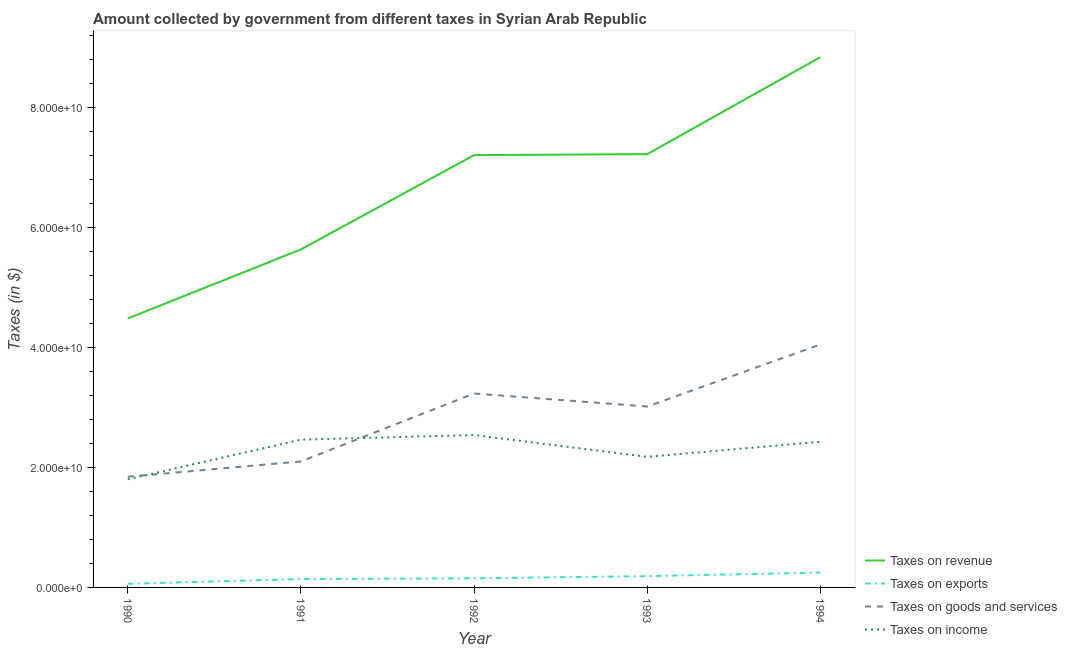How many different coloured lines are there?
Keep it short and to the point. 4. What is the amount collected as tax on revenue in 1994?
Your answer should be compact. 8.84e+1. Across all years, what is the maximum amount collected as tax on goods?
Your answer should be compact. 4.05e+1. Across all years, what is the minimum amount collected as tax on exports?
Your response must be concise. 6.04e+08. In which year was the amount collected as tax on revenue minimum?
Keep it short and to the point. 1990. What is the total amount collected as tax on income in the graph?
Ensure brevity in your answer.  1.14e+11. What is the difference between the amount collected as tax on income in 1990 and that in 1992?
Your answer should be compact. -7.38e+09. What is the difference between the amount collected as tax on goods in 1993 and the amount collected as tax on income in 1992?
Provide a short and direct response. 4.76e+09. What is the average amount collected as tax on goods per year?
Offer a terse response. 2.85e+1. In the year 1990, what is the difference between the amount collected as tax on revenue and amount collected as tax on exports?
Ensure brevity in your answer.  4.42e+1. In how many years, is the amount collected as tax on goods greater than 76000000000 $?
Keep it short and to the point. 0. What is the ratio of the amount collected as tax on exports in 1991 to that in 1994?
Offer a terse response. 0.56. Is the difference between the amount collected as tax on revenue in 1991 and 1992 greater than the difference between the amount collected as tax on exports in 1991 and 1992?
Provide a succinct answer. No. What is the difference between the highest and the second highest amount collected as tax on goods?
Provide a short and direct response. 8.17e+09. What is the difference between the highest and the lowest amount collected as tax on goods?
Your answer should be compact. 2.21e+1. Is the sum of the amount collected as tax on exports in 1992 and 1993 greater than the maximum amount collected as tax on revenue across all years?
Provide a succinct answer. No. Is it the case that in every year, the sum of the amount collected as tax on revenue and amount collected as tax on exports is greater than the amount collected as tax on goods?
Provide a succinct answer. Yes. Does the amount collected as tax on goods monotonically increase over the years?
Your answer should be very brief. No. Is the amount collected as tax on goods strictly greater than the amount collected as tax on exports over the years?
Offer a terse response. Yes. Is the amount collected as tax on goods strictly less than the amount collected as tax on income over the years?
Provide a short and direct response. No. How many lines are there?
Provide a short and direct response. 4. How many years are there in the graph?
Ensure brevity in your answer.  5. Does the graph contain any zero values?
Make the answer very short. No. Where does the legend appear in the graph?
Your response must be concise. Bottom right. What is the title of the graph?
Make the answer very short. Amount collected by government from different taxes in Syrian Arab Republic. Does "WHO" appear as one of the legend labels in the graph?
Keep it short and to the point. No. What is the label or title of the X-axis?
Your answer should be compact. Year. What is the label or title of the Y-axis?
Keep it short and to the point. Taxes (in $). What is the Taxes (in $) of Taxes on revenue in 1990?
Offer a terse response. 4.48e+1. What is the Taxes (in $) in Taxes on exports in 1990?
Your answer should be very brief. 6.04e+08. What is the Taxes (in $) in Taxes on goods and services in 1990?
Your answer should be compact. 1.85e+1. What is the Taxes (in $) in Taxes on income in 1990?
Make the answer very short. 1.80e+1. What is the Taxes (in $) in Taxes on revenue in 1991?
Offer a terse response. 5.64e+1. What is the Taxes (in $) in Taxes on exports in 1991?
Ensure brevity in your answer.  1.39e+09. What is the Taxes (in $) of Taxes on goods and services in 1991?
Make the answer very short. 2.10e+1. What is the Taxes (in $) of Taxes on income in 1991?
Give a very brief answer. 2.46e+1. What is the Taxes (in $) in Taxes on revenue in 1992?
Your answer should be very brief. 7.21e+1. What is the Taxes (in $) in Taxes on exports in 1992?
Provide a succinct answer. 1.52e+09. What is the Taxes (in $) in Taxes on goods and services in 1992?
Your response must be concise. 3.23e+1. What is the Taxes (in $) of Taxes on income in 1992?
Give a very brief answer. 2.54e+1. What is the Taxes (in $) of Taxes on revenue in 1993?
Give a very brief answer. 7.22e+1. What is the Taxes (in $) in Taxes on exports in 1993?
Offer a terse response. 1.88e+09. What is the Taxes (in $) of Taxes on goods and services in 1993?
Ensure brevity in your answer.  3.02e+1. What is the Taxes (in $) of Taxes on income in 1993?
Offer a very short reply. 2.18e+1. What is the Taxes (in $) in Taxes on revenue in 1994?
Your answer should be compact. 8.84e+1. What is the Taxes (in $) in Taxes on exports in 1994?
Provide a short and direct response. 2.48e+09. What is the Taxes (in $) in Taxes on goods and services in 1994?
Offer a terse response. 4.05e+1. What is the Taxes (in $) of Taxes on income in 1994?
Offer a terse response. 2.43e+1. Across all years, what is the maximum Taxes (in $) in Taxes on revenue?
Ensure brevity in your answer.  8.84e+1. Across all years, what is the maximum Taxes (in $) in Taxes on exports?
Provide a succinct answer. 2.48e+09. Across all years, what is the maximum Taxes (in $) of Taxes on goods and services?
Provide a short and direct response. 4.05e+1. Across all years, what is the maximum Taxes (in $) in Taxes on income?
Make the answer very short. 2.54e+1. Across all years, what is the minimum Taxes (in $) in Taxes on revenue?
Keep it short and to the point. 4.48e+1. Across all years, what is the minimum Taxes (in $) of Taxes on exports?
Ensure brevity in your answer.  6.04e+08. Across all years, what is the minimum Taxes (in $) in Taxes on goods and services?
Provide a short and direct response. 1.85e+1. Across all years, what is the minimum Taxes (in $) in Taxes on income?
Offer a terse response. 1.80e+1. What is the total Taxes (in $) in Taxes on revenue in the graph?
Offer a terse response. 3.34e+11. What is the total Taxes (in $) of Taxes on exports in the graph?
Your answer should be very brief. 7.88e+09. What is the total Taxes (in $) of Taxes on goods and services in the graph?
Your answer should be very brief. 1.42e+11. What is the total Taxes (in $) in Taxes on income in the graph?
Ensure brevity in your answer.  1.14e+11. What is the difference between the Taxes (in $) in Taxes on revenue in 1990 and that in 1991?
Offer a very short reply. -1.15e+1. What is the difference between the Taxes (in $) in Taxes on exports in 1990 and that in 1991?
Give a very brief answer. -7.88e+08. What is the difference between the Taxes (in $) in Taxes on goods and services in 1990 and that in 1991?
Your response must be concise. -2.56e+09. What is the difference between the Taxes (in $) of Taxes on income in 1990 and that in 1991?
Ensure brevity in your answer.  -6.61e+09. What is the difference between the Taxes (in $) in Taxes on revenue in 1990 and that in 1992?
Keep it short and to the point. -2.72e+1. What is the difference between the Taxes (in $) of Taxes on exports in 1990 and that in 1992?
Make the answer very short. -9.19e+08. What is the difference between the Taxes (in $) of Taxes on goods and services in 1990 and that in 1992?
Keep it short and to the point. -1.39e+1. What is the difference between the Taxes (in $) of Taxes on income in 1990 and that in 1992?
Make the answer very short. -7.38e+09. What is the difference between the Taxes (in $) in Taxes on revenue in 1990 and that in 1993?
Provide a succinct answer. -2.74e+1. What is the difference between the Taxes (in $) of Taxes on exports in 1990 and that in 1993?
Offer a very short reply. -1.28e+09. What is the difference between the Taxes (in $) of Taxes on goods and services in 1990 and that in 1993?
Your answer should be compact. -1.17e+1. What is the difference between the Taxes (in $) in Taxes on income in 1990 and that in 1993?
Offer a terse response. -3.75e+09. What is the difference between the Taxes (in $) of Taxes on revenue in 1990 and that in 1994?
Provide a short and direct response. -4.36e+1. What is the difference between the Taxes (in $) in Taxes on exports in 1990 and that in 1994?
Provide a short and direct response. -1.87e+09. What is the difference between the Taxes (in $) in Taxes on goods and services in 1990 and that in 1994?
Provide a succinct answer. -2.21e+1. What is the difference between the Taxes (in $) in Taxes on income in 1990 and that in 1994?
Provide a succinct answer. -6.26e+09. What is the difference between the Taxes (in $) in Taxes on revenue in 1991 and that in 1992?
Keep it short and to the point. -1.57e+1. What is the difference between the Taxes (in $) in Taxes on exports in 1991 and that in 1992?
Offer a terse response. -1.31e+08. What is the difference between the Taxes (in $) of Taxes on goods and services in 1991 and that in 1992?
Provide a short and direct response. -1.13e+1. What is the difference between the Taxes (in $) of Taxes on income in 1991 and that in 1992?
Your answer should be compact. -7.67e+08. What is the difference between the Taxes (in $) of Taxes on revenue in 1991 and that in 1993?
Your answer should be compact. -1.59e+1. What is the difference between the Taxes (in $) of Taxes on exports in 1991 and that in 1993?
Provide a succinct answer. -4.92e+08. What is the difference between the Taxes (in $) in Taxes on goods and services in 1991 and that in 1993?
Your answer should be very brief. -9.16e+09. What is the difference between the Taxes (in $) of Taxes on income in 1991 and that in 1993?
Give a very brief answer. 2.86e+09. What is the difference between the Taxes (in $) of Taxes on revenue in 1991 and that in 1994?
Keep it short and to the point. -3.21e+1. What is the difference between the Taxes (in $) of Taxes on exports in 1991 and that in 1994?
Provide a short and direct response. -1.08e+09. What is the difference between the Taxes (in $) in Taxes on goods and services in 1991 and that in 1994?
Provide a short and direct response. -1.95e+1. What is the difference between the Taxes (in $) of Taxes on income in 1991 and that in 1994?
Your answer should be very brief. 3.50e+08. What is the difference between the Taxes (in $) of Taxes on revenue in 1992 and that in 1993?
Your answer should be compact. -1.62e+08. What is the difference between the Taxes (in $) in Taxes on exports in 1992 and that in 1993?
Your answer should be compact. -3.61e+08. What is the difference between the Taxes (in $) of Taxes on goods and services in 1992 and that in 1993?
Your answer should be compact. 2.17e+09. What is the difference between the Taxes (in $) of Taxes on income in 1992 and that in 1993?
Your answer should be compact. 3.63e+09. What is the difference between the Taxes (in $) of Taxes on revenue in 1992 and that in 1994?
Your response must be concise. -1.63e+1. What is the difference between the Taxes (in $) of Taxes on exports in 1992 and that in 1994?
Keep it short and to the point. -9.54e+08. What is the difference between the Taxes (in $) in Taxes on goods and services in 1992 and that in 1994?
Offer a very short reply. -8.17e+09. What is the difference between the Taxes (in $) of Taxes on income in 1992 and that in 1994?
Keep it short and to the point. 1.12e+09. What is the difference between the Taxes (in $) in Taxes on revenue in 1993 and that in 1994?
Give a very brief answer. -1.62e+1. What is the difference between the Taxes (in $) of Taxes on exports in 1993 and that in 1994?
Your answer should be very brief. -5.93e+08. What is the difference between the Taxes (in $) in Taxes on goods and services in 1993 and that in 1994?
Keep it short and to the point. -1.03e+1. What is the difference between the Taxes (in $) of Taxes on income in 1993 and that in 1994?
Your answer should be compact. -2.52e+09. What is the difference between the Taxes (in $) of Taxes on revenue in 1990 and the Taxes (in $) of Taxes on exports in 1991?
Provide a short and direct response. 4.35e+1. What is the difference between the Taxes (in $) of Taxes on revenue in 1990 and the Taxes (in $) of Taxes on goods and services in 1991?
Your response must be concise. 2.38e+1. What is the difference between the Taxes (in $) in Taxes on revenue in 1990 and the Taxes (in $) in Taxes on income in 1991?
Your answer should be compact. 2.02e+1. What is the difference between the Taxes (in $) of Taxes on exports in 1990 and the Taxes (in $) of Taxes on goods and services in 1991?
Keep it short and to the point. -2.04e+1. What is the difference between the Taxes (in $) of Taxes on exports in 1990 and the Taxes (in $) of Taxes on income in 1991?
Provide a short and direct response. -2.40e+1. What is the difference between the Taxes (in $) of Taxes on goods and services in 1990 and the Taxes (in $) of Taxes on income in 1991?
Your response must be concise. -6.19e+09. What is the difference between the Taxes (in $) of Taxes on revenue in 1990 and the Taxes (in $) of Taxes on exports in 1992?
Give a very brief answer. 4.33e+1. What is the difference between the Taxes (in $) in Taxes on revenue in 1990 and the Taxes (in $) in Taxes on goods and services in 1992?
Your answer should be compact. 1.25e+1. What is the difference between the Taxes (in $) in Taxes on revenue in 1990 and the Taxes (in $) in Taxes on income in 1992?
Keep it short and to the point. 1.94e+1. What is the difference between the Taxes (in $) in Taxes on exports in 1990 and the Taxes (in $) in Taxes on goods and services in 1992?
Your answer should be compact. -3.17e+1. What is the difference between the Taxes (in $) in Taxes on exports in 1990 and the Taxes (in $) in Taxes on income in 1992?
Keep it short and to the point. -2.48e+1. What is the difference between the Taxes (in $) in Taxes on goods and services in 1990 and the Taxes (in $) in Taxes on income in 1992?
Your answer should be very brief. -6.96e+09. What is the difference between the Taxes (in $) of Taxes on revenue in 1990 and the Taxes (in $) of Taxes on exports in 1993?
Keep it short and to the point. 4.30e+1. What is the difference between the Taxes (in $) of Taxes on revenue in 1990 and the Taxes (in $) of Taxes on goods and services in 1993?
Offer a terse response. 1.47e+1. What is the difference between the Taxes (in $) in Taxes on revenue in 1990 and the Taxes (in $) in Taxes on income in 1993?
Your answer should be very brief. 2.31e+1. What is the difference between the Taxes (in $) of Taxes on exports in 1990 and the Taxes (in $) of Taxes on goods and services in 1993?
Give a very brief answer. -2.96e+1. What is the difference between the Taxes (in $) of Taxes on exports in 1990 and the Taxes (in $) of Taxes on income in 1993?
Make the answer very short. -2.12e+1. What is the difference between the Taxes (in $) in Taxes on goods and services in 1990 and the Taxes (in $) in Taxes on income in 1993?
Provide a succinct answer. -3.32e+09. What is the difference between the Taxes (in $) in Taxes on revenue in 1990 and the Taxes (in $) in Taxes on exports in 1994?
Make the answer very short. 4.24e+1. What is the difference between the Taxes (in $) in Taxes on revenue in 1990 and the Taxes (in $) in Taxes on goods and services in 1994?
Offer a very short reply. 4.34e+09. What is the difference between the Taxes (in $) of Taxes on revenue in 1990 and the Taxes (in $) of Taxes on income in 1994?
Keep it short and to the point. 2.06e+1. What is the difference between the Taxes (in $) of Taxes on exports in 1990 and the Taxes (in $) of Taxes on goods and services in 1994?
Offer a terse response. -3.99e+1. What is the difference between the Taxes (in $) in Taxes on exports in 1990 and the Taxes (in $) in Taxes on income in 1994?
Ensure brevity in your answer.  -2.37e+1. What is the difference between the Taxes (in $) of Taxes on goods and services in 1990 and the Taxes (in $) of Taxes on income in 1994?
Offer a terse response. -5.84e+09. What is the difference between the Taxes (in $) of Taxes on revenue in 1991 and the Taxes (in $) of Taxes on exports in 1992?
Keep it short and to the point. 5.48e+1. What is the difference between the Taxes (in $) of Taxes on revenue in 1991 and the Taxes (in $) of Taxes on goods and services in 1992?
Your response must be concise. 2.40e+1. What is the difference between the Taxes (in $) of Taxes on revenue in 1991 and the Taxes (in $) of Taxes on income in 1992?
Your answer should be very brief. 3.10e+1. What is the difference between the Taxes (in $) in Taxes on exports in 1991 and the Taxes (in $) in Taxes on goods and services in 1992?
Provide a succinct answer. -3.09e+1. What is the difference between the Taxes (in $) in Taxes on exports in 1991 and the Taxes (in $) in Taxes on income in 1992?
Offer a terse response. -2.40e+1. What is the difference between the Taxes (in $) in Taxes on goods and services in 1991 and the Taxes (in $) in Taxes on income in 1992?
Your answer should be compact. -4.40e+09. What is the difference between the Taxes (in $) in Taxes on revenue in 1991 and the Taxes (in $) in Taxes on exports in 1993?
Your answer should be compact. 5.45e+1. What is the difference between the Taxes (in $) in Taxes on revenue in 1991 and the Taxes (in $) in Taxes on goods and services in 1993?
Give a very brief answer. 2.62e+1. What is the difference between the Taxes (in $) in Taxes on revenue in 1991 and the Taxes (in $) in Taxes on income in 1993?
Provide a succinct answer. 3.46e+1. What is the difference between the Taxes (in $) of Taxes on exports in 1991 and the Taxes (in $) of Taxes on goods and services in 1993?
Ensure brevity in your answer.  -2.88e+1. What is the difference between the Taxes (in $) of Taxes on exports in 1991 and the Taxes (in $) of Taxes on income in 1993?
Your answer should be very brief. -2.04e+1. What is the difference between the Taxes (in $) in Taxes on goods and services in 1991 and the Taxes (in $) in Taxes on income in 1993?
Provide a short and direct response. -7.69e+08. What is the difference between the Taxes (in $) in Taxes on revenue in 1991 and the Taxes (in $) in Taxes on exports in 1994?
Keep it short and to the point. 5.39e+1. What is the difference between the Taxes (in $) in Taxes on revenue in 1991 and the Taxes (in $) in Taxes on goods and services in 1994?
Your answer should be compact. 1.59e+1. What is the difference between the Taxes (in $) of Taxes on revenue in 1991 and the Taxes (in $) of Taxes on income in 1994?
Keep it short and to the point. 3.21e+1. What is the difference between the Taxes (in $) in Taxes on exports in 1991 and the Taxes (in $) in Taxes on goods and services in 1994?
Offer a very short reply. -3.91e+1. What is the difference between the Taxes (in $) of Taxes on exports in 1991 and the Taxes (in $) of Taxes on income in 1994?
Your answer should be very brief. -2.29e+1. What is the difference between the Taxes (in $) of Taxes on goods and services in 1991 and the Taxes (in $) of Taxes on income in 1994?
Your response must be concise. -3.28e+09. What is the difference between the Taxes (in $) in Taxes on revenue in 1992 and the Taxes (in $) in Taxes on exports in 1993?
Provide a succinct answer. 7.02e+1. What is the difference between the Taxes (in $) of Taxes on revenue in 1992 and the Taxes (in $) of Taxes on goods and services in 1993?
Give a very brief answer. 4.19e+1. What is the difference between the Taxes (in $) in Taxes on revenue in 1992 and the Taxes (in $) in Taxes on income in 1993?
Make the answer very short. 5.03e+1. What is the difference between the Taxes (in $) in Taxes on exports in 1992 and the Taxes (in $) in Taxes on goods and services in 1993?
Your response must be concise. -2.86e+1. What is the difference between the Taxes (in $) in Taxes on exports in 1992 and the Taxes (in $) in Taxes on income in 1993?
Your response must be concise. -2.03e+1. What is the difference between the Taxes (in $) in Taxes on goods and services in 1992 and the Taxes (in $) in Taxes on income in 1993?
Your answer should be very brief. 1.06e+1. What is the difference between the Taxes (in $) in Taxes on revenue in 1992 and the Taxes (in $) in Taxes on exports in 1994?
Provide a short and direct response. 6.96e+1. What is the difference between the Taxes (in $) of Taxes on revenue in 1992 and the Taxes (in $) of Taxes on goods and services in 1994?
Your response must be concise. 3.16e+1. What is the difference between the Taxes (in $) of Taxes on revenue in 1992 and the Taxes (in $) of Taxes on income in 1994?
Provide a succinct answer. 4.78e+1. What is the difference between the Taxes (in $) in Taxes on exports in 1992 and the Taxes (in $) in Taxes on goods and services in 1994?
Provide a short and direct response. -3.90e+1. What is the difference between the Taxes (in $) of Taxes on exports in 1992 and the Taxes (in $) of Taxes on income in 1994?
Provide a succinct answer. -2.28e+1. What is the difference between the Taxes (in $) in Taxes on goods and services in 1992 and the Taxes (in $) in Taxes on income in 1994?
Ensure brevity in your answer.  8.05e+09. What is the difference between the Taxes (in $) in Taxes on revenue in 1993 and the Taxes (in $) in Taxes on exports in 1994?
Offer a terse response. 6.98e+1. What is the difference between the Taxes (in $) of Taxes on revenue in 1993 and the Taxes (in $) of Taxes on goods and services in 1994?
Offer a very short reply. 3.17e+1. What is the difference between the Taxes (in $) in Taxes on revenue in 1993 and the Taxes (in $) in Taxes on income in 1994?
Provide a succinct answer. 4.80e+1. What is the difference between the Taxes (in $) in Taxes on exports in 1993 and the Taxes (in $) in Taxes on goods and services in 1994?
Make the answer very short. -3.86e+1. What is the difference between the Taxes (in $) in Taxes on exports in 1993 and the Taxes (in $) in Taxes on income in 1994?
Offer a terse response. -2.24e+1. What is the difference between the Taxes (in $) in Taxes on goods and services in 1993 and the Taxes (in $) in Taxes on income in 1994?
Your answer should be very brief. 5.88e+09. What is the average Taxes (in $) in Taxes on revenue per year?
Your answer should be compact. 6.68e+1. What is the average Taxes (in $) in Taxes on exports per year?
Your response must be concise. 1.58e+09. What is the average Taxes (in $) of Taxes on goods and services per year?
Your answer should be very brief. 2.85e+1. What is the average Taxes (in $) of Taxes on income per year?
Your response must be concise. 2.28e+1. In the year 1990, what is the difference between the Taxes (in $) in Taxes on revenue and Taxes (in $) in Taxes on exports?
Give a very brief answer. 4.42e+1. In the year 1990, what is the difference between the Taxes (in $) of Taxes on revenue and Taxes (in $) of Taxes on goods and services?
Your response must be concise. 2.64e+1. In the year 1990, what is the difference between the Taxes (in $) in Taxes on revenue and Taxes (in $) in Taxes on income?
Your response must be concise. 2.68e+1. In the year 1990, what is the difference between the Taxes (in $) in Taxes on exports and Taxes (in $) in Taxes on goods and services?
Ensure brevity in your answer.  -1.78e+1. In the year 1990, what is the difference between the Taxes (in $) of Taxes on exports and Taxes (in $) of Taxes on income?
Make the answer very short. -1.74e+1. In the year 1990, what is the difference between the Taxes (in $) of Taxes on goods and services and Taxes (in $) of Taxes on income?
Keep it short and to the point. 4.23e+08. In the year 1991, what is the difference between the Taxes (in $) in Taxes on revenue and Taxes (in $) in Taxes on exports?
Make the answer very short. 5.50e+1. In the year 1991, what is the difference between the Taxes (in $) of Taxes on revenue and Taxes (in $) of Taxes on goods and services?
Ensure brevity in your answer.  3.54e+1. In the year 1991, what is the difference between the Taxes (in $) in Taxes on revenue and Taxes (in $) in Taxes on income?
Offer a very short reply. 3.17e+1. In the year 1991, what is the difference between the Taxes (in $) of Taxes on exports and Taxes (in $) of Taxes on goods and services?
Your answer should be compact. -1.96e+1. In the year 1991, what is the difference between the Taxes (in $) of Taxes on exports and Taxes (in $) of Taxes on income?
Your answer should be very brief. -2.32e+1. In the year 1991, what is the difference between the Taxes (in $) of Taxes on goods and services and Taxes (in $) of Taxes on income?
Your response must be concise. -3.63e+09. In the year 1992, what is the difference between the Taxes (in $) of Taxes on revenue and Taxes (in $) of Taxes on exports?
Give a very brief answer. 7.06e+1. In the year 1992, what is the difference between the Taxes (in $) of Taxes on revenue and Taxes (in $) of Taxes on goods and services?
Provide a succinct answer. 3.97e+1. In the year 1992, what is the difference between the Taxes (in $) of Taxes on revenue and Taxes (in $) of Taxes on income?
Your answer should be very brief. 4.67e+1. In the year 1992, what is the difference between the Taxes (in $) of Taxes on exports and Taxes (in $) of Taxes on goods and services?
Your answer should be very brief. -3.08e+1. In the year 1992, what is the difference between the Taxes (in $) of Taxes on exports and Taxes (in $) of Taxes on income?
Give a very brief answer. -2.39e+1. In the year 1992, what is the difference between the Taxes (in $) of Taxes on goods and services and Taxes (in $) of Taxes on income?
Provide a short and direct response. 6.93e+09. In the year 1993, what is the difference between the Taxes (in $) of Taxes on revenue and Taxes (in $) of Taxes on exports?
Provide a short and direct response. 7.04e+1. In the year 1993, what is the difference between the Taxes (in $) of Taxes on revenue and Taxes (in $) of Taxes on goods and services?
Provide a short and direct response. 4.21e+1. In the year 1993, what is the difference between the Taxes (in $) of Taxes on revenue and Taxes (in $) of Taxes on income?
Provide a short and direct response. 5.05e+1. In the year 1993, what is the difference between the Taxes (in $) in Taxes on exports and Taxes (in $) in Taxes on goods and services?
Your answer should be very brief. -2.83e+1. In the year 1993, what is the difference between the Taxes (in $) of Taxes on exports and Taxes (in $) of Taxes on income?
Provide a short and direct response. -1.99e+1. In the year 1993, what is the difference between the Taxes (in $) in Taxes on goods and services and Taxes (in $) in Taxes on income?
Offer a very short reply. 8.39e+09. In the year 1994, what is the difference between the Taxes (in $) in Taxes on revenue and Taxes (in $) in Taxes on exports?
Offer a terse response. 8.59e+1. In the year 1994, what is the difference between the Taxes (in $) in Taxes on revenue and Taxes (in $) in Taxes on goods and services?
Give a very brief answer. 4.79e+1. In the year 1994, what is the difference between the Taxes (in $) of Taxes on revenue and Taxes (in $) of Taxes on income?
Your answer should be compact. 6.41e+1. In the year 1994, what is the difference between the Taxes (in $) in Taxes on exports and Taxes (in $) in Taxes on goods and services?
Ensure brevity in your answer.  -3.80e+1. In the year 1994, what is the difference between the Taxes (in $) in Taxes on exports and Taxes (in $) in Taxes on income?
Give a very brief answer. -2.18e+1. In the year 1994, what is the difference between the Taxes (in $) of Taxes on goods and services and Taxes (in $) of Taxes on income?
Your response must be concise. 1.62e+1. What is the ratio of the Taxes (in $) of Taxes on revenue in 1990 to that in 1991?
Your answer should be compact. 0.8. What is the ratio of the Taxes (in $) of Taxes on exports in 1990 to that in 1991?
Provide a short and direct response. 0.43. What is the ratio of the Taxes (in $) of Taxes on goods and services in 1990 to that in 1991?
Keep it short and to the point. 0.88. What is the ratio of the Taxes (in $) in Taxes on income in 1990 to that in 1991?
Your answer should be compact. 0.73. What is the ratio of the Taxes (in $) in Taxes on revenue in 1990 to that in 1992?
Your answer should be compact. 0.62. What is the ratio of the Taxes (in $) of Taxes on exports in 1990 to that in 1992?
Give a very brief answer. 0.4. What is the ratio of the Taxes (in $) in Taxes on goods and services in 1990 to that in 1992?
Give a very brief answer. 0.57. What is the ratio of the Taxes (in $) in Taxes on income in 1990 to that in 1992?
Make the answer very short. 0.71. What is the ratio of the Taxes (in $) of Taxes on revenue in 1990 to that in 1993?
Give a very brief answer. 0.62. What is the ratio of the Taxes (in $) of Taxes on exports in 1990 to that in 1993?
Your answer should be compact. 0.32. What is the ratio of the Taxes (in $) in Taxes on goods and services in 1990 to that in 1993?
Keep it short and to the point. 0.61. What is the ratio of the Taxes (in $) of Taxes on income in 1990 to that in 1993?
Ensure brevity in your answer.  0.83. What is the ratio of the Taxes (in $) of Taxes on revenue in 1990 to that in 1994?
Keep it short and to the point. 0.51. What is the ratio of the Taxes (in $) of Taxes on exports in 1990 to that in 1994?
Keep it short and to the point. 0.24. What is the ratio of the Taxes (in $) of Taxes on goods and services in 1990 to that in 1994?
Your answer should be very brief. 0.46. What is the ratio of the Taxes (in $) of Taxes on income in 1990 to that in 1994?
Your answer should be very brief. 0.74. What is the ratio of the Taxes (in $) in Taxes on revenue in 1991 to that in 1992?
Make the answer very short. 0.78. What is the ratio of the Taxes (in $) in Taxes on exports in 1991 to that in 1992?
Offer a terse response. 0.91. What is the ratio of the Taxes (in $) of Taxes on goods and services in 1991 to that in 1992?
Give a very brief answer. 0.65. What is the ratio of the Taxes (in $) in Taxes on income in 1991 to that in 1992?
Keep it short and to the point. 0.97. What is the ratio of the Taxes (in $) of Taxes on revenue in 1991 to that in 1993?
Provide a succinct answer. 0.78. What is the ratio of the Taxes (in $) of Taxes on exports in 1991 to that in 1993?
Provide a succinct answer. 0.74. What is the ratio of the Taxes (in $) of Taxes on goods and services in 1991 to that in 1993?
Ensure brevity in your answer.  0.7. What is the ratio of the Taxes (in $) in Taxes on income in 1991 to that in 1993?
Provide a succinct answer. 1.13. What is the ratio of the Taxes (in $) in Taxes on revenue in 1991 to that in 1994?
Keep it short and to the point. 0.64. What is the ratio of the Taxes (in $) in Taxes on exports in 1991 to that in 1994?
Give a very brief answer. 0.56. What is the ratio of the Taxes (in $) of Taxes on goods and services in 1991 to that in 1994?
Your answer should be very brief. 0.52. What is the ratio of the Taxes (in $) in Taxes on income in 1991 to that in 1994?
Provide a short and direct response. 1.01. What is the ratio of the Taxes (in $) in Taxes on exports in 1992 to that in 1993?
Keep it short and to the point. 0.81. What is the ratio of the Taxes (in $) of Taxes on goods and services in 1992 to that in 1993?
Keep it short and to the point. 1.07. What is the ratio of the Taxes (in $) of Taxes on income in 1992 to that in 1993?
Your response must be concise. 1.17. What is the ratio of the Taxes (in $) of Taxes on revenue in 1992 to that in 1994?
Make the answer very short. 0.82. What is the ratio of the Taxes (in $) in Taxes on exports in 1992 to that in 1994?
Provide a succinct answer. 0.61. What is the ratio of the Taxes (in $) in Taxes on goods and services in 1992 to that in 1994?
Offer a terse response. 0.8. What is the ratio of the Taxes (in $) of Taxes on income in 1992 to that in 1994?
Your response must be concise. 1.05. What is the ratio of the Taxes (in $) in Taxes on revenue in 1993 to that in 1994?
Give a very brief answer. 0.82. What is the ratio of the Taxes (in $) in Taxes on exports in 1993 to that in 1994?
Offer a very short reply. 0.76. What is the ratio of the Taxes (in $) of Taxes on goods and services in 1993 to that in 1994?
Your answer should be very brief. 0.74. What is the ratio of the Taxes (in $) of Taxes on income in 1993 to that in 1994?
Provide a short and direct response. 0.9. What is the difference between the highest and the second highest Taxes (in $) in Taxes on revenue?
Your answer should be compact. 1.62e+1. What is the difference between the highest and the second highest Taxes (in $) of Taxes on exports?
Provide a succinct answer. 5.93e+08. What is the difference between the highest and the second highest Taxes (in $) in Taxes on goods and services?
Your answer should be compact. 8.17e+09. What is the difference between the highest and the second highest Taxes (in $) of Taxes on income?
Your answer should be compact. 7.67e+08. What is the difference between the highest and the lowest Taxes (in $) in Taxes on revenue?
Your response must be concise. 4.36e+1. What is the difference between the highest and the lowest Taxes (in $) in Taxes on exports?
Provide a succinct answer. 1.87e+09. What is the difference between the highest and the lowest Taxes (in $) in Taxes on goods and services?
Your answer should be very brief. 2.21e+1. What is the difference between the highest and the lowest Taxes (in $) in Taxes on income?
Provide a short and direct response. 7.38e+09. 